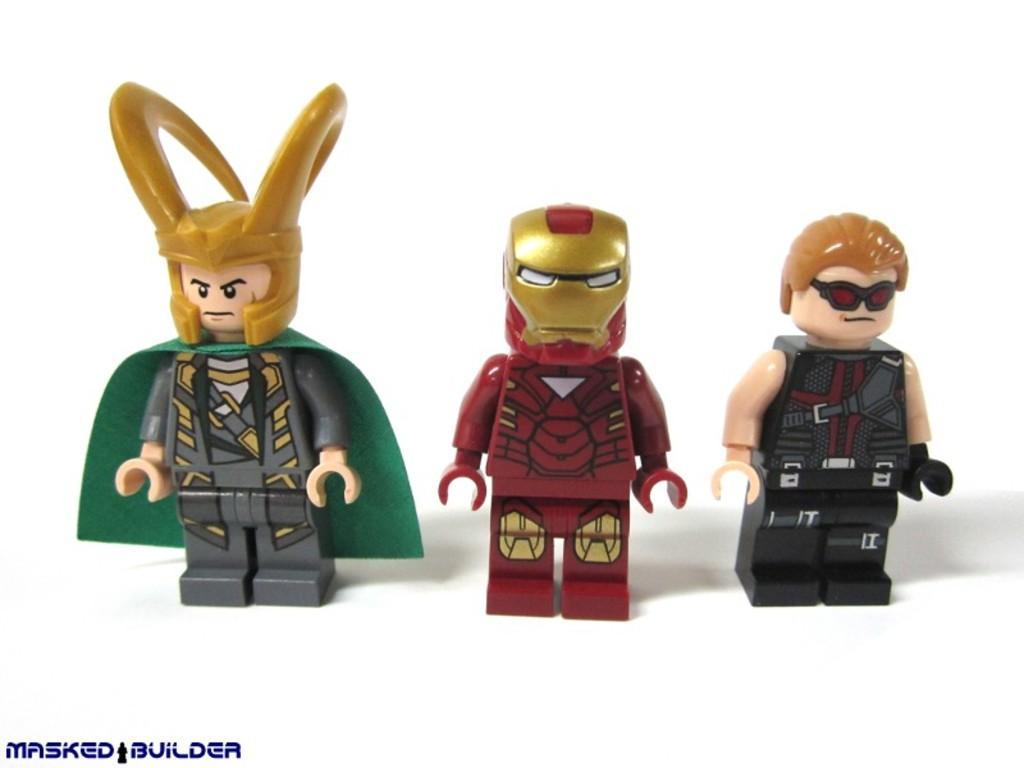Describe this image in one or two sentences. In this image I can see three toys which are grey, green, maroon, gold, black and cream in color on the white colored surface and I can see the white colored background. 